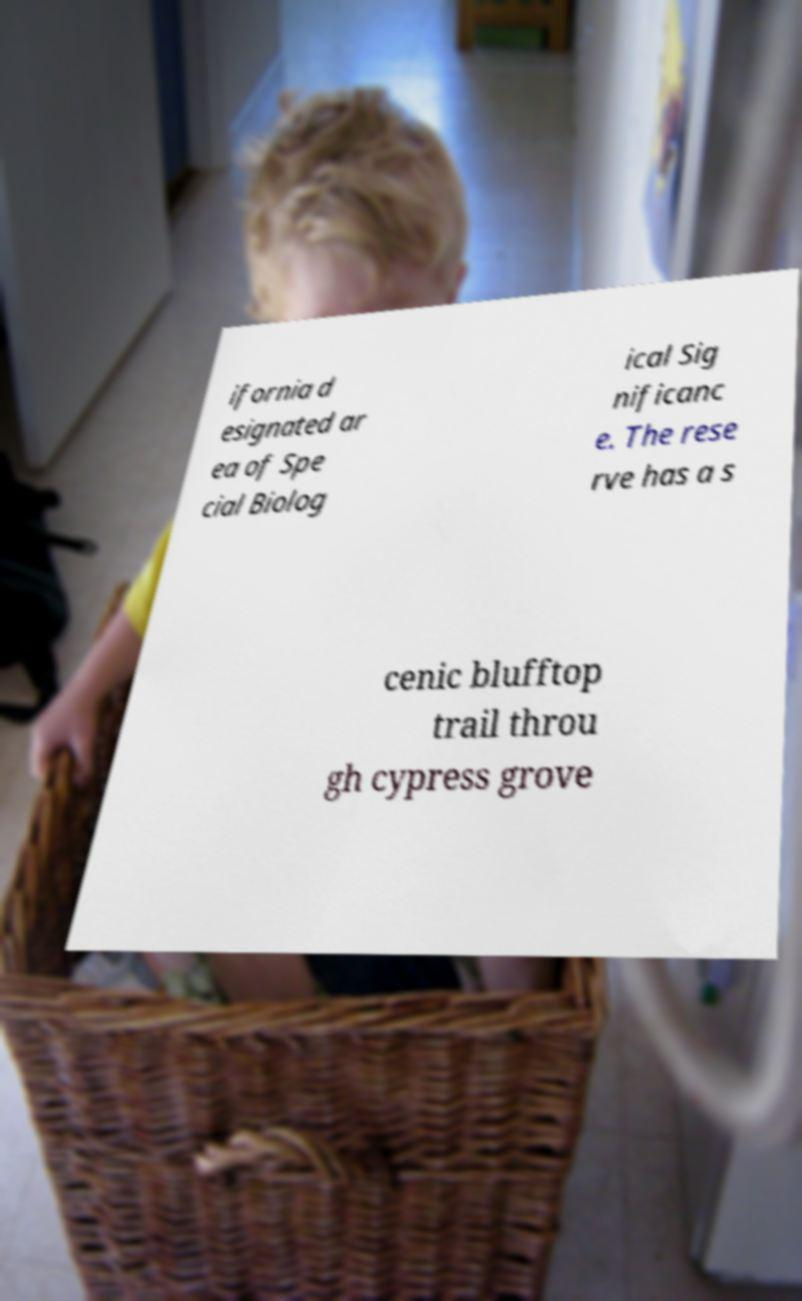Can you read and provide the text displayed in the image?This photo seems to have some interesting text. Can you extract and type it out for me? ifornia d esignated ar ea of Spe cial Biolog ical Sig nificanc e. The rese rve has a s cenic blufftop trail throu gh cypress grove 